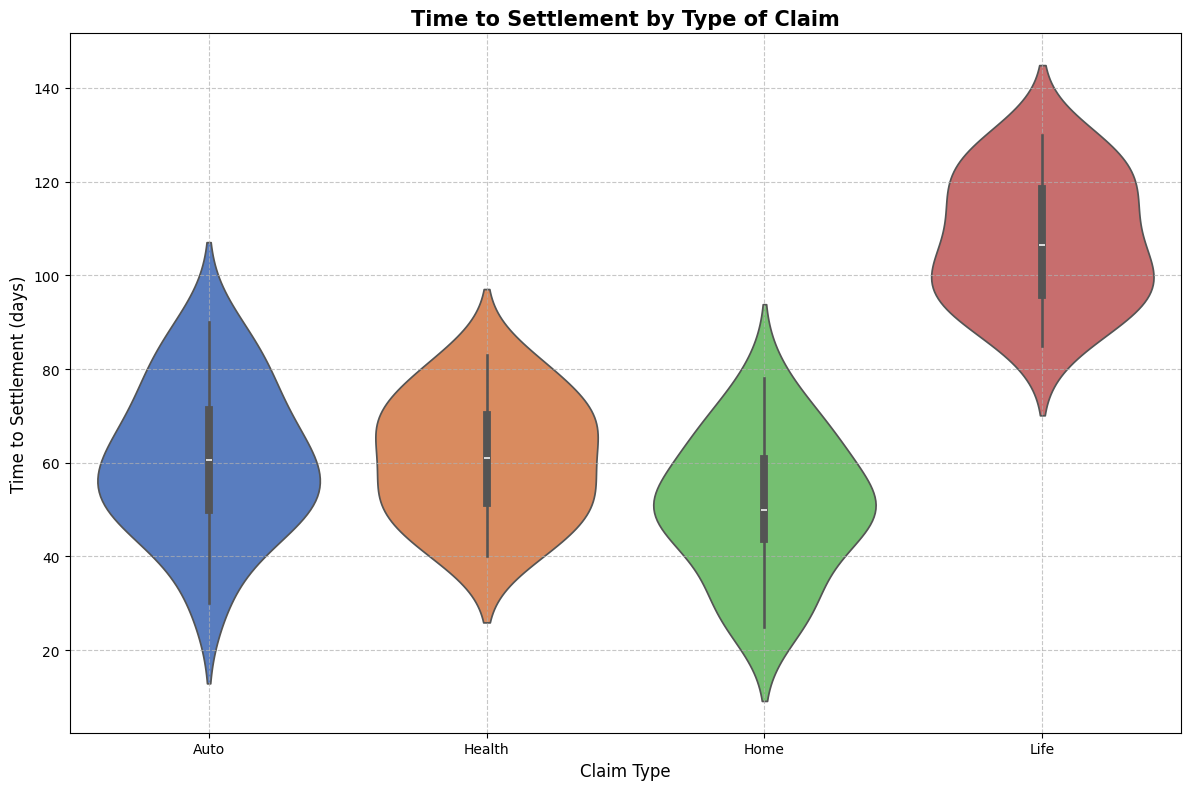What's the median time to settlement for Auto claims? The median is the middle value when all times are sorted in ascending order. For Auto claims, the sorted times are: 30, 40, 45, 49, 50, 50, 53, 53, 55, 60, 61, 62, 65, 66, 70, 75, 78, 80, 85, 90. The median is the average of the 10th and 11th values, which are 55 and 60. So, the median is (55 + 60) / 2 = 57.5 days.
Answer: 57.5 days Which claim type has the shortest lower whisker in the violin plot? The lower whisker represents the minimum time to settlement. Based on the visual attributes in the plot, Home claims have the shortest lower whisker, indicating the shortest minimum time to settlement.
Answer: Home What is the approximate range of settlement times for Life claims? The range is the difference between the maximum and minimum times. From the plot, Life claims range from approximately 85 to 130 days. The range is thus 130 - 85 = 45 days.
Answer: 45 days Which claim type shows the highest variability in time to settlement? Variability can be assessed by looking at the spread and width of the violin. The plot shows that Life claims have the widest spread, indicating the highest variability in settlement times.
Answer: Life Compare the median settlement time between Home and Health claims. Which one is higher? The medians are the central values of the distributions. For Home claims, the median appears around 50 days. For Health claims, the median appears around 60 days. Therefore, the median for Health claims is higher.
Answer: Health What is the predominant settlement time range for Auto claims? The predominant settlement time range is where the plot is the thickest. For Auto claims, this thick portion appears around 50 to 70 days.
Answer: 50 to 70 days If you group the claims into fast (<= 50 days) and slow (> 50 days), which claim type has the highest proportion of slow claims? The proportion can be inferred from the area of the violin plot above 50 days. Life claims have the largest portion of their distribution above 50 days, indicating the highest proportion of slow claims.
Answer: Life Are there any claim types with clear outliers in their time to settlement? Outliers are points that significantly differ from the rest of the data. In the plot, no clear outliers are visually indicated by distinct points away from the bulk of each distribution.
Answer: No How does the spread of Health claim settlement times compare to Auto claim settlement times? The spread is the range of values covered by the violin. Health claims have a slightly wider spread (around 40 to 83 days) compared to Auto claims (30 to 90 days). This indicates that Auto claims have a broader range but Health claims are more tightly packed in their core range.
Answer: Auto claims have a broader range 